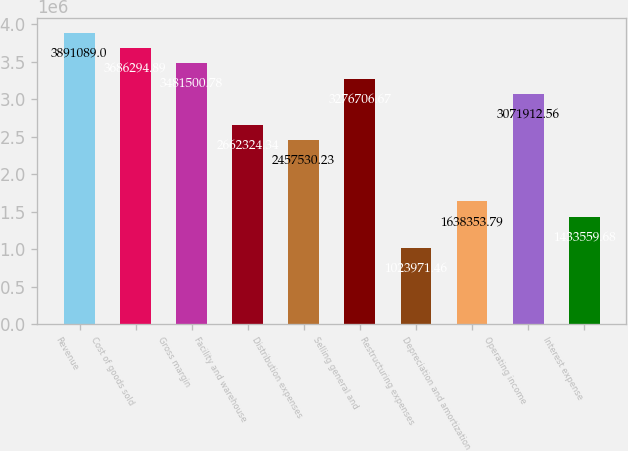Convert chart to OTSL. <chart><loc_0><loc_0><loc_500><loc_500><bar_chart><fcel>Revenue<fcel>Cost of goods sold<fcel>Gross margin<fcel>Facility and warehouse<fcel>Distribution expenses<fcel>Selling general and<fcel>Restructuring expenses<fcel>Depreciation and amortization<fcel>Operating income<fcel>Interest expense<nl><fcel>3.89109e+06<fcel>3.68629e+06<fcel>3.4815e+06<fcel>2.66232e+06<fcel>2.45753e+06<fcel>3.27671e+06<fcel>1.02397e+06<fcel>1.63835e+06<fcel>3.07191e+06<fcel>1.43356e+06<nl></chart> 